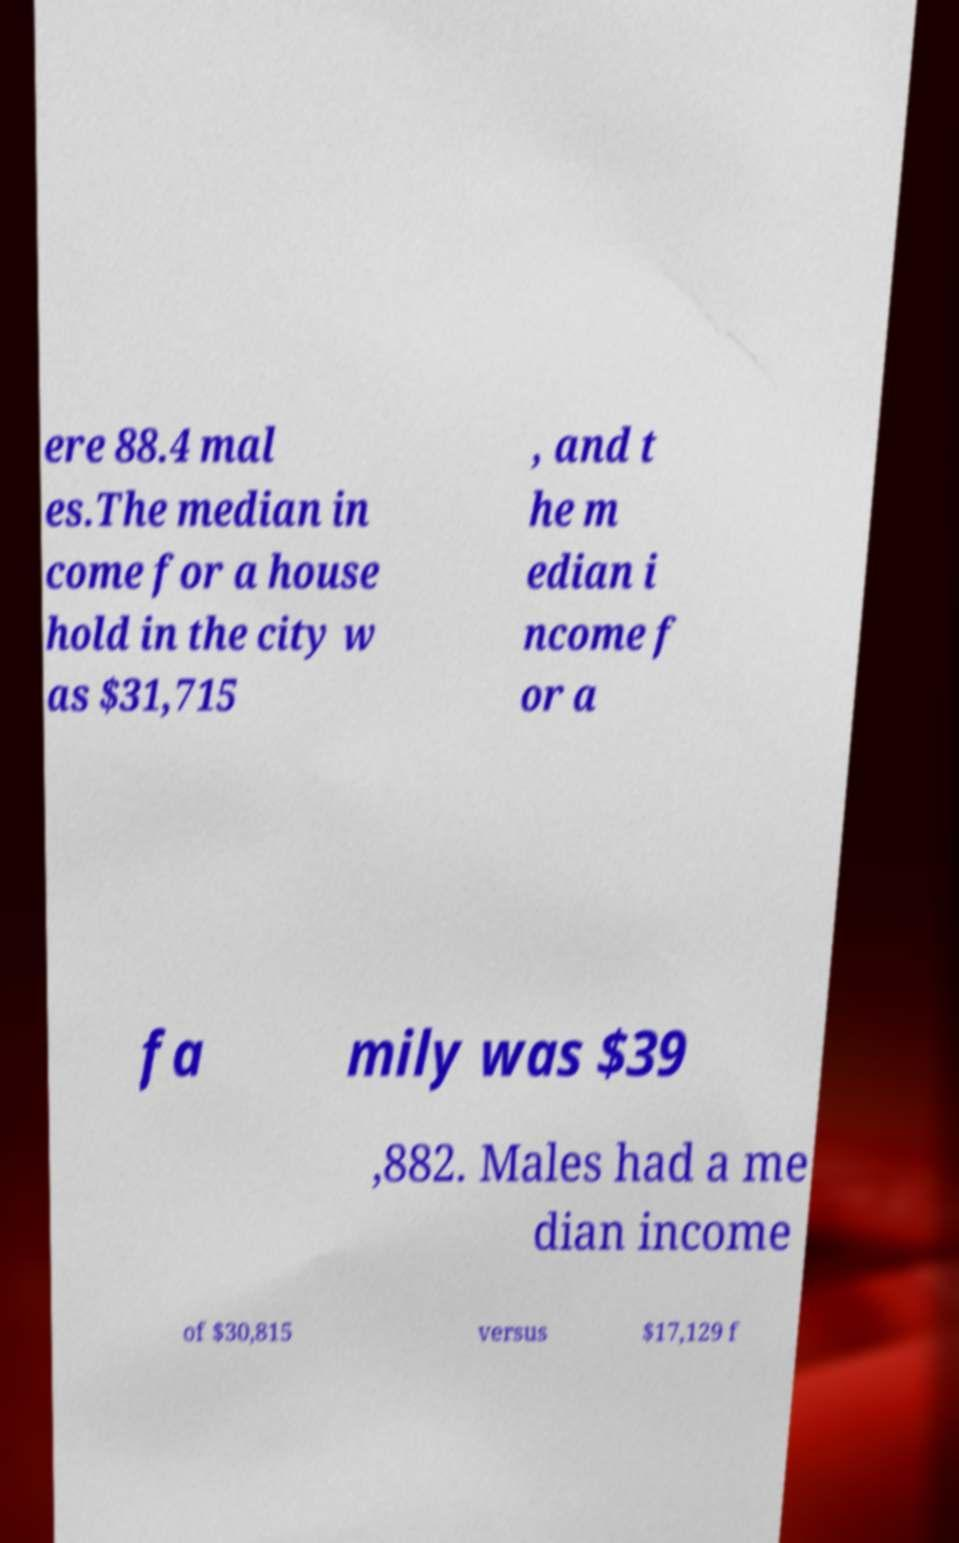Could you assist in decoding the text presented in this image and type it out clearly? ere 88.4 mal es.The median in come for a house hold in the city w as $31,715 , and t he m edian i ncome f or a fa mily was $39 ,882. Males had a me dian income of $30,815 versus $17,129 f 